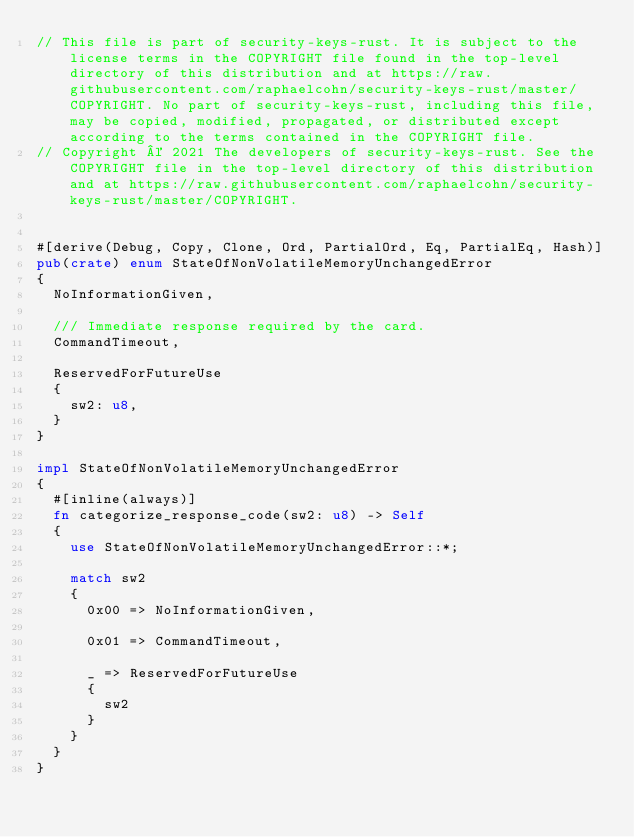<code> <loc_0><loc_0><loc_500><loc_500><_Rust_>// This file is part of security-keys-rust. It is subject to the license terms in the COPYRIGHT file found in the top-level directory of this distribution and at https://raw.githubusercontent.com/raphaelcohn/security-keys-rust/master/COPYRIGHT. No part of security-keys-rust, including this file, may be copied, modified, propagated, or distributed except according to the terms contained in the COPYRIGHT file.
// Copyright © 2021 The developers of security-keys-rust. See the COPYRIGHT file in the top-level directory of this distribution and at https://raw.githubusercontent.com/raphaelcohn/security-keys-rust/master/COPYRIGHT.


#[derive(Debug, Copy, Clone, Ord, PartialOrd, Eq, PartialEq, Hash)]
pub(crate) enum StateOfNonVolatileMemoryUnchangedError
{
	NoInformationGiven,
	
	/// Immediate response required by the card.
	CommandTimeout,
	
	ReservedForFutureUse
	{
		sw2: u8,
	}
}

impl StateOfNonVolatileMemoryUnchangedError
{
	#[inline(always)]
	fn categorize_response_code(sw2: u8) -> Self
	{
		use StateOfNonVolatileMemoryUnchangedError::*;
		
		match sw2
		{
			0x00 => NoInformationGiven,
			
			0x01 => CommandTimeout,
			
			_ => ReservedForFutureUse
			{
				sw2
			}
		}
	}
}
</code> 